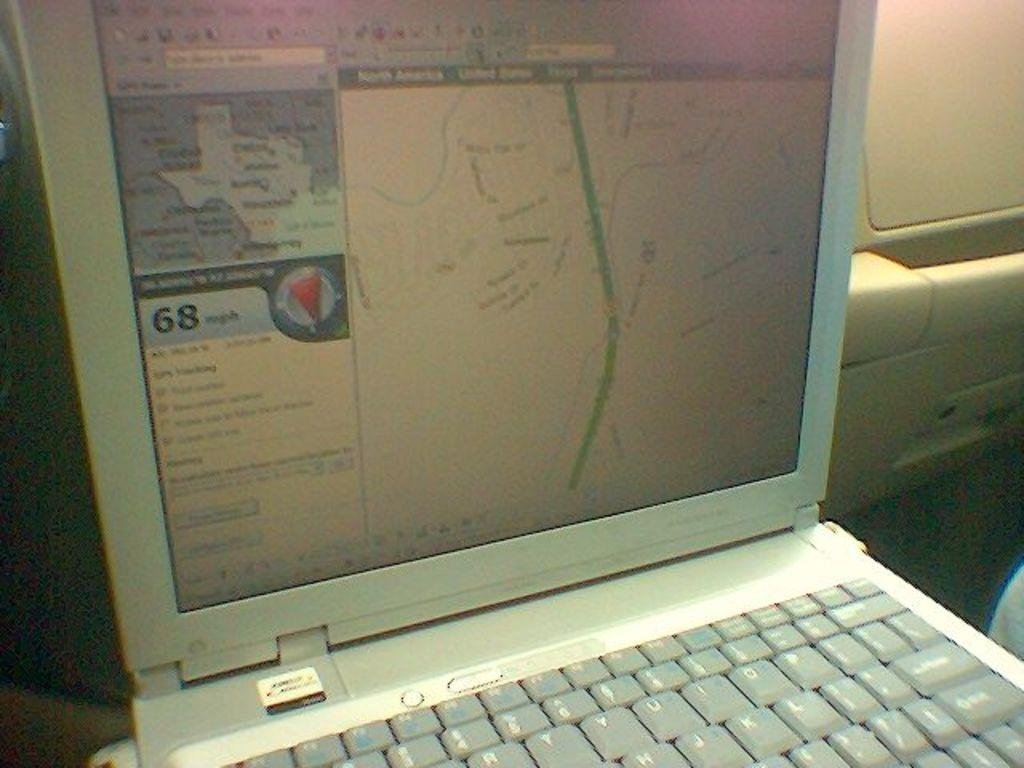<image>
Render a clear and concise summary of the photo. A laptop screen shows a map of Texas and the number 68 in large font. 